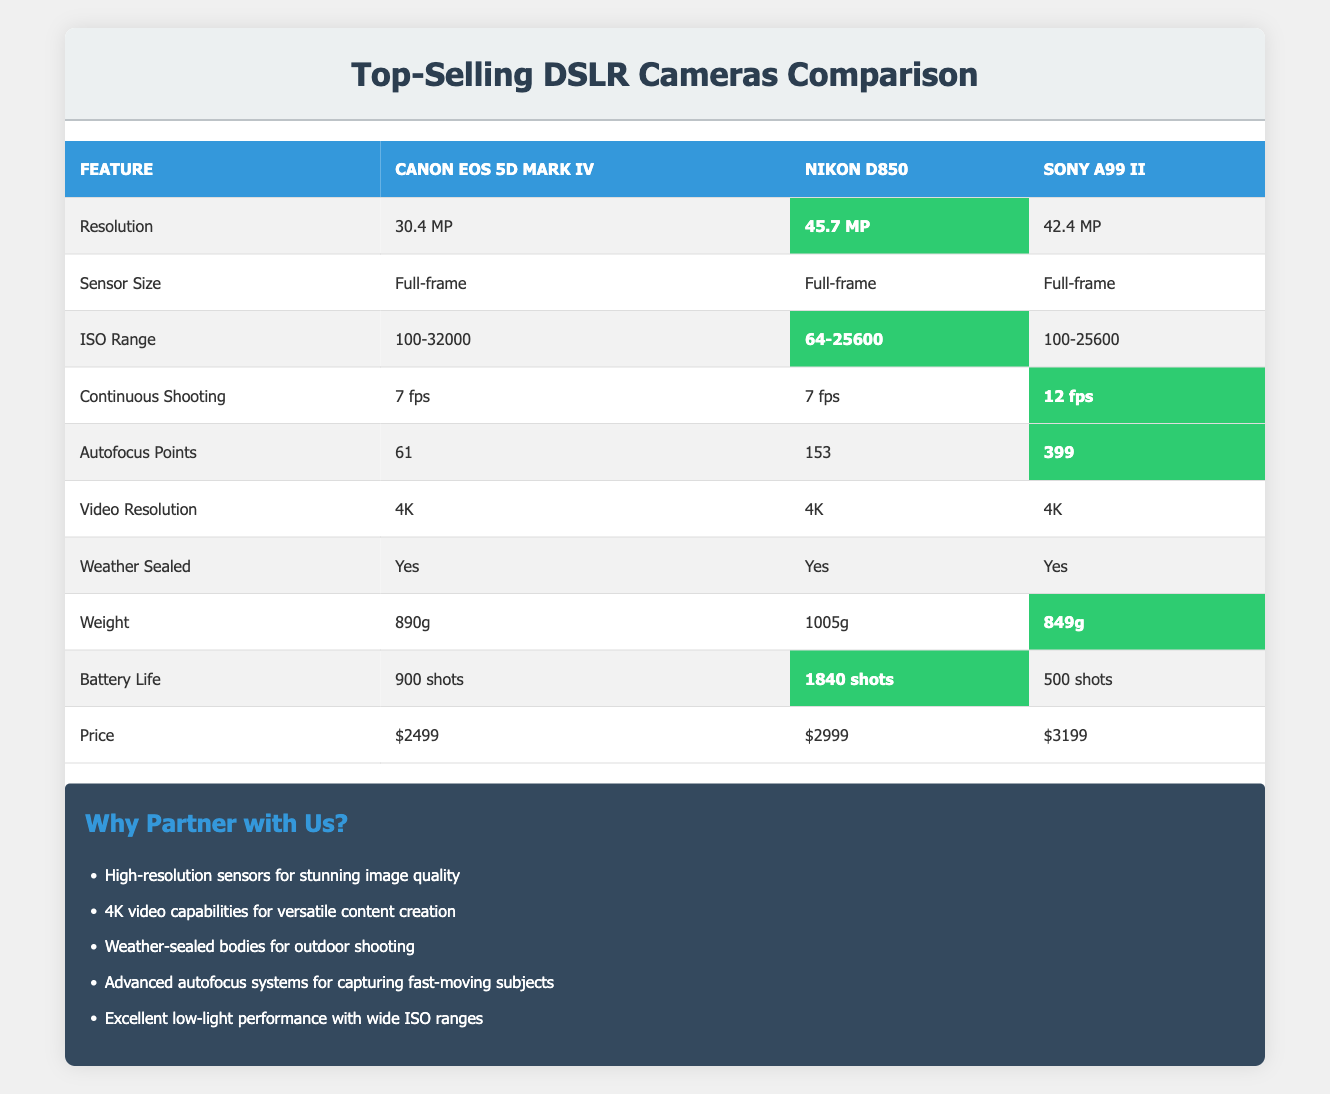What is the resolution of the Nikon D850? The table lists the specifications for each camera model. Looking under the model "Nikon D850," the resolution is noted as "45.7 MP."
Answer: 45.7 MP Which camera has the longest battery life? To find the longest battery life, we compare the battery life of each model: Canon EOS 5D Mark IV has 900 shots, Nikon D850 has 1840 shots, and Sony A99 II has 500 shots. The highest value is 1840 shots for the Nikon D850.
Answer: Nikon D850 Is the Sony A99 II weather-sealed? The table indicates whether each camera is weather-sealed. For the Sony A99 II, the table shows "Yes" under the weather-sealed feature.
Answer: Yes What is the weight difference between the lightest and heaviest cameras? The weight of Canon EOS 5D Mark IV is 890g, Nikon D850 is 1005g, and Sony A99 II is 849g. The heaviest is Nikon D850 at 1005g and the lightest is Sony A99 II at 849g. The difference is 1005g - 849g = 156g.
Answer: 156g Which camera offers the most autofocus points? Reviewing the autofocus points listed for each model: Canon EOS 5D Mark IV has 61, Nikon D850 has 153, and Sony A99 II has 399. The highest number of autofocus points is 399 for the Sony A99 II.
Answer: Sony A99 II What is the average resolution of the three models? The resolutions are: Canon EOS 5D Mark IV: 30.4 MP, Nikon D850: 45.7 MP, Sony A99 II: 42.4 MP. First, convert these to a common format: 30.4 + 45.7 + 42.4 = 118.5 MP. To find the average, divide by the number of models: 118.5 MP / 3 = 39.5 MP.
Answer: 39.5 MP Is the Canon EOS 5D Mark IV more affordable than the Nikon D850? The table shows the prices: Canon EOS 5D Mark IV is $2499 and Nikon D850 is $2999. Since $2499 is less than $2999, the Canon EOS 5D Mark IV is more affordable.
Answer: Yes How many more continuous shooting frames per second does the Sony A99 II have compared to the Canon EOS 5D Mark IV? The continuous shooting rate for the Canon EOS 5D Mark IV is 7 fps, and for the Sony A99 II is 12 fps. To find the difference, we subtract: 12 fps - 7 fps = 5 fps.
Answer: 5 fps 